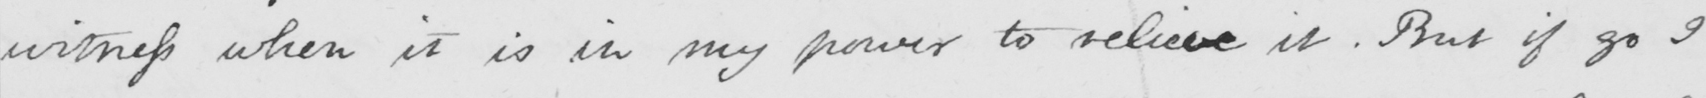What does this handwritten line say? witness when it is in my power to relieve it . But if go I 